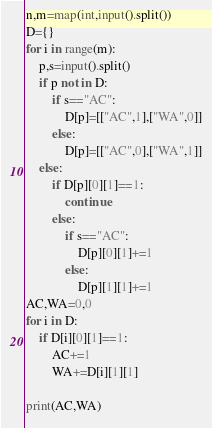<code> <loc_0><loc_0><loc_500><loc_500><_Python_>n,m=map(int,input().split())
D={}
for i in range(m):
    p,s=input().split()
    if p not in D:
        if s=="AC":
            D[p]=[["AC",1],["WA",0]]
        else:
            D[p]=[["AC",0],["WA",1]]
    else:
        if D[p][0][1]==1:
            continue
        else:
            if s=="AC":
                D[p][0][1]+=1
            else:
                D[p][1][1]+=1
AC,WA=0,0
for i in D:
    if D[i][0][1]==1:
        AC+=1
        WA+=D[i][1][1]

print(AC,WA)</code> 